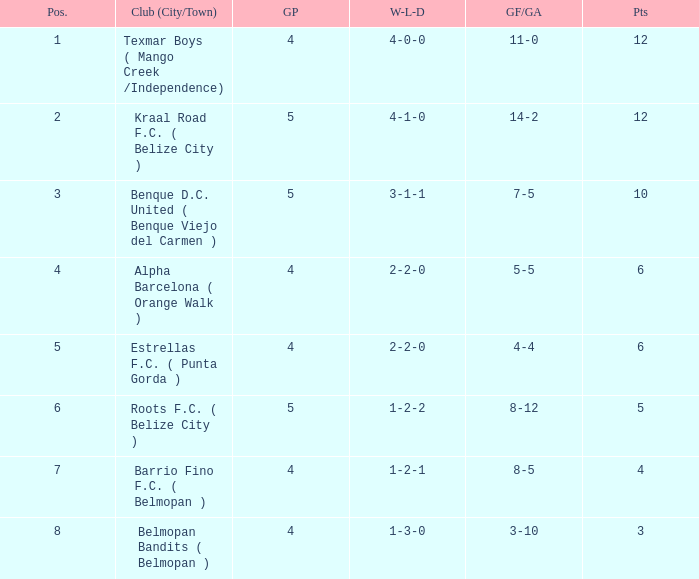Who is the the club (city/town) with goals for/against being 14-2 Kraal Road F.C. ( Belize City ). 